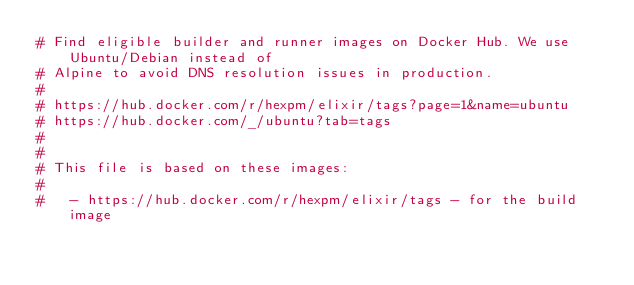<code> <loc_0><loc_0><loc_500><loc_500><_Dockerfile_># Find eligible builder and runner images on Docker Hub. We use Ubuntu/Debian instead of
# Alpine to avoid DNS resolution issues in production.
#
# https://hub.docker.com/r/hexpm/elixir/tags?page=1&name=ubuntu
# https://hub.docker.com/_/ubuntu?tab=tags
#
#
# This file is based on these images:
#
#   - https://hub.docker.com/r/hexpm/elixir/tags - for the build image</code> 